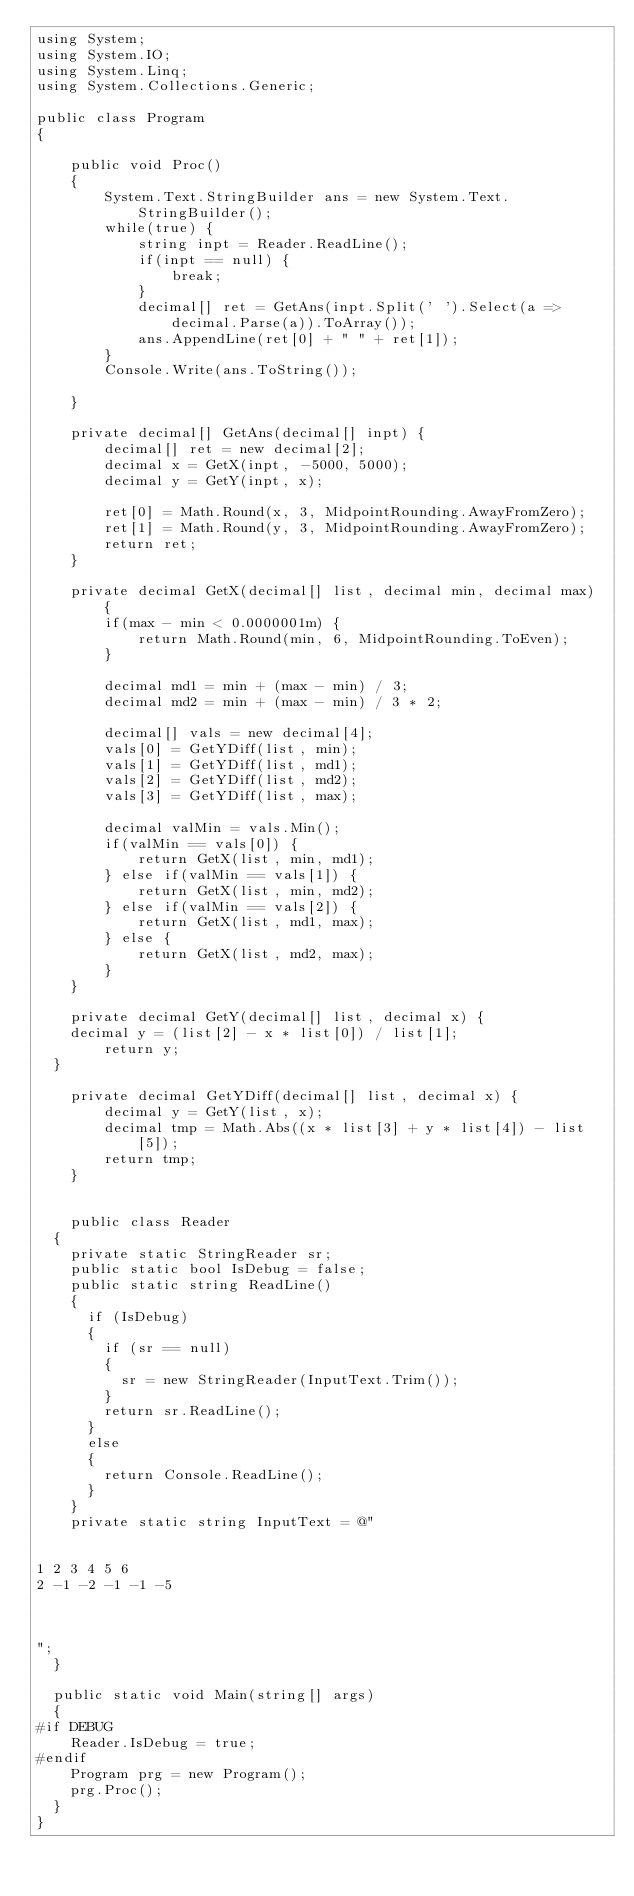<code> <loc_0><loc_0><loc_500><loc_500><_C#_>using System;
using System.IO;
using System.Linq;
using System.Collections.Generic;

public class Program
{

    public void Proc()
    {
        System.Text.StringBuilder ans = new System.Text.StringBuilder();
        while(true) {
            string inpt = Reader.ReadLine();
            if(inpt == null) {
                break;
            }
            decimal[] ret = GetAns(inpt.Split(' ').Select(a => decimal.Parse(a)).ToArray());
            ans.AppendLine(ret[0] + " " + ret[1]);
        }
        Console.Write(ans.ToString());
        
    }

    private decimal[] GetAns(decimal[] inpt) {
        decimal[] ret = new decimal[2];
        decimal x = GetX(inpt, -5000, 5000);
        decimal y = GetY(inpt, x);

        ret[0] = Math.Round(x, 3, MidpointRounding.AwayFromZero);
        ret[1] = Math.Round(y, 3, MidpointRounding.AwayFromZero);
        return ret;
    }

    private decimal GetX(decimal[] list, decimal min, decimal max) {
        if(max - min < 0.0000001m) {
            return Math.Round(min, 6, MidpointRounding.ToEven);
        }

        decimal md1 = min + (max - min) / 3;
        decimal md2 = min + (max - min) / 3 * 2;

        decimal[] vals = new decimal[4];
        vals[0] = GetYDiff(list, min);
        vals[1] = GetYDiff(list, md1);
        vals[2] = GetYDiff(list, md2);
        vals[3] = GetYDiff(list, max);

        decimal valMin = vals.Min();
        if(valMin == vals[0]) {
            return GetX(list, min, md1);
        } else if(valMin == vals[1]) {
            return GetX(list, min, md2);
        } else if(valMin == vals[2]) {
            return GetX(list, md1, max);
        } else {
            return GetX(list, md2, max);
        }
    }

    private decimal GetY(decimal[] list, decimal x) {
		decimal y = (list[2] - x * list[0]) / list[1];
        return y;
	}

    private decimal GetYDiff(decimal[] list, decimal x) {
        decimal y = GetY(list, x);
        decimal tmp = Math.Abs((x * list[3] + y * list[4]) - list[5]);
        return tmp;
    }


    public class Reader
	{
		private static StringReader sr;
		public static bool IsDebug = false;
		public static string ReadLine()
		{
			if (IsDebug)
			{
				if (sr == null)
				{
					sr = new StringReader(InputText.Trim());
				}
				return sr.ReadLine();
			}
			else
			{
				return Console.ReadLine();
			}
		}
		private static string InputText = @"


1 2 3 4 5 6
2 -1 -2 -1 -1 -5



";
	}

	public static void Main(string[] args)
	{
#if DEBUG
		Reader.IsDebug = true;
#endif
		Program prg = new Program();
		prg.Proc();
	}
}</code> 